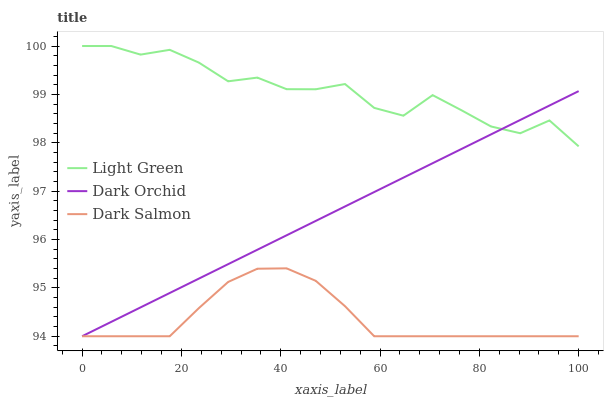Does Dark Salmon have the minimum area under the curve?
Answer yes or no. Yes. Does Light Green have the maximum area under the curve?
Answer yes or no. Yes. Does Light Green have the minimum area under the curve?
Answer yes or no. No. Does Dark Salmon have the maximum area under the curve?
Answer yes or no. No. Is Dark Orchid the smoothest?
Answer yes or no. Yes. Is Light Green the roughest?
Answer yes or no. Yes. Is Dark Salmon the smoothest?
Answer yes or no. No. Is Dark Salmon the roughest?
Answer yes or no. No. Does Dark Orchid have the lowest value?
Answer yes or no. Yes. Does Light Green have the lowest value?
Answer yes or no. No. Does Light Green have the highest value?
Answer yes or no. Yes. Does Dark Salmon have the highest value?
Answer yes or no. No. Is Dark Salmon less than Light Green?
Answer yes or no. Yes. Is Light Green greater than Dark Salmon?
Answer yes or no. Yes. Does Dark Orchid intersect Light Green?
Answer yes or no. Yes. Is Dark Orchid less than Light Green?
Answer yes or no. No. Is Dark Orchid greater than Light Green?
Answer yes or no. No. Does Dark Salmon intersect Light Green?
Answer yes or no. No. 